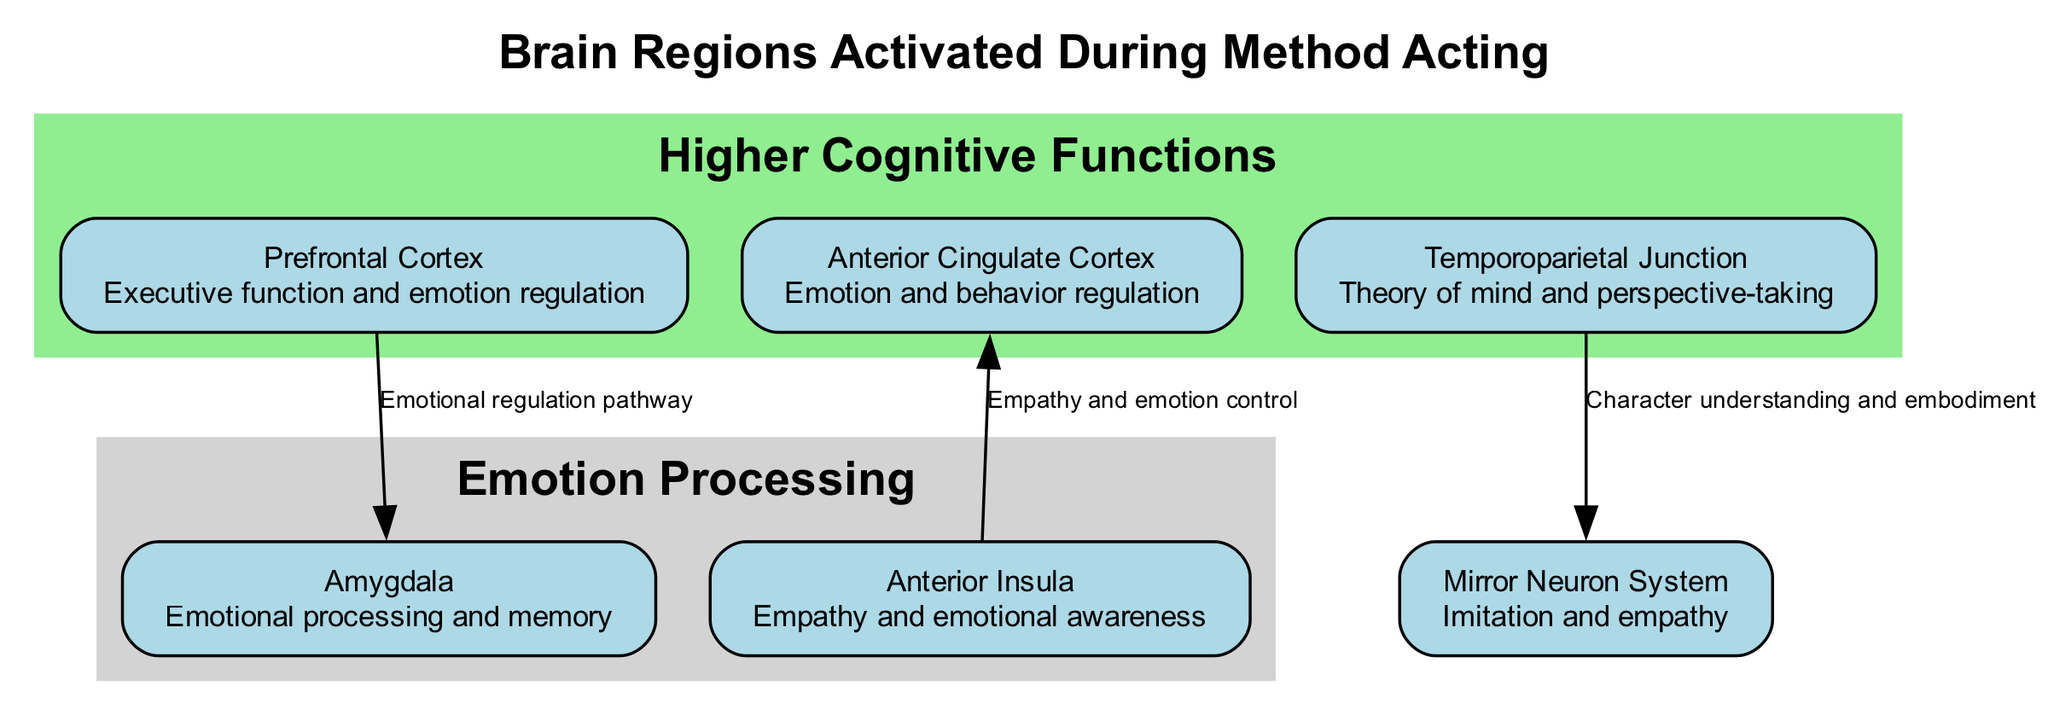What is the main function of the Prefrontal Cortex? The Prefrontal Cortex is associated with executive function and emotion regulation, as indicated in the diagram's description for that node.
Answer: Executive function and emotion regulation Which two regions are primarily concerned with emotional processing? The diagram highlights the Amygdala and the Anterior Insula as regions associated with emotional processing; both are included under 'Emotion Processing' in the clusters.
Answer: Amygdala and Anterior Insula How many nodes are displayed in the diagram? The diagram features a total of six nodes that represent different brain regions activated during method acting.
Answer: Six What is the connection between the Anterior Insula and the Anterior Cingulate Cortex? The diagram describes their connection as related to empathy and emotion control. This indicates that these two regions communicate and are functionally linked in their roles.
Answer: Empathy and emotion control Which brain region is connected to the Temporoparietal Junction? The Temporoparietal Junction is connected to the Mirror Neuron System in the diagram, indicating a pathway for understanding character and embodiment in method acting.
Answer: Mirror Neuron System How many edges are represented in the diagram? The diagram shows three edges, which indicate the relationships between the various nodes (brain regions) that are activated during method acting.
Answer: Three What role does the Mirror Neuron System play according to the diagram? The diagram indicates that the Mirror Neuron System is associated with imitation and empathy, essential for method actors to effectively embody their characters.
Answer: Imitation and empathy Which brain region is involved with perspective-taking? The Temporoparietal Junction, as indicated in the diagram, is specifically noted for its association with theory of mind and perspective-taking functions.
Answer: Temporoparietal Junction What is the common theme among the nodes grouped in the 'Emotion Processing' cluster? The common theme among the nodes in the 'Emotion Processing' cluster, which includes the Amygdala and Anterior Insula, revolves around emotional awareness and empathy functions, integral to acting methods involving deep emotional engagement.
Answer: Emotional awareness and empathy functions 